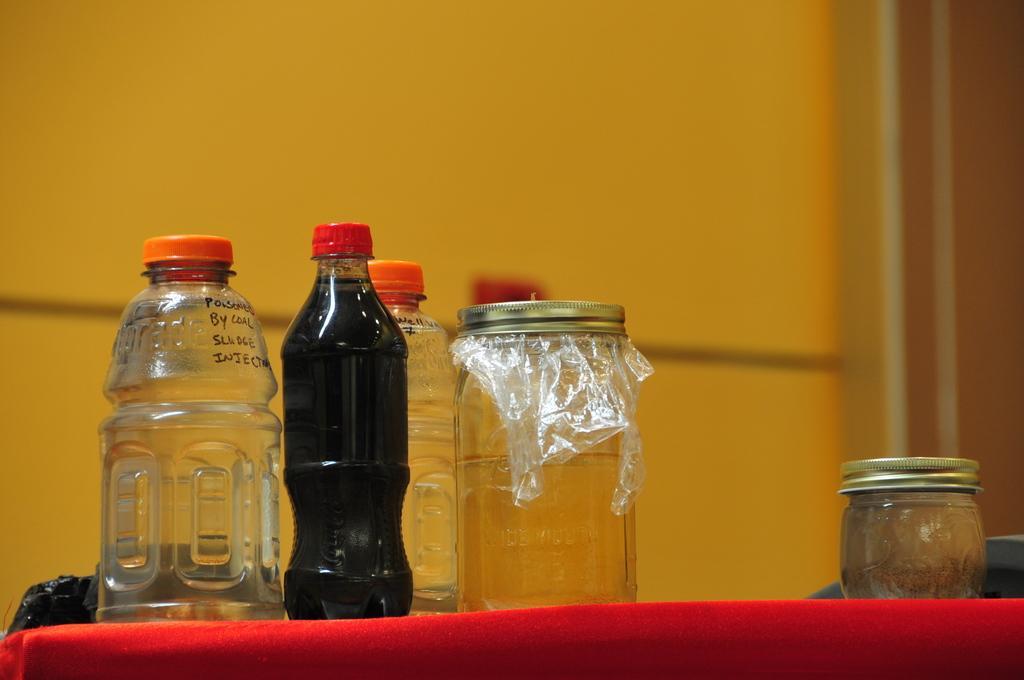In one or two sentences, can you explain what this image depicts? In this picture there are three bottles and two jars. There is a red cloth. 